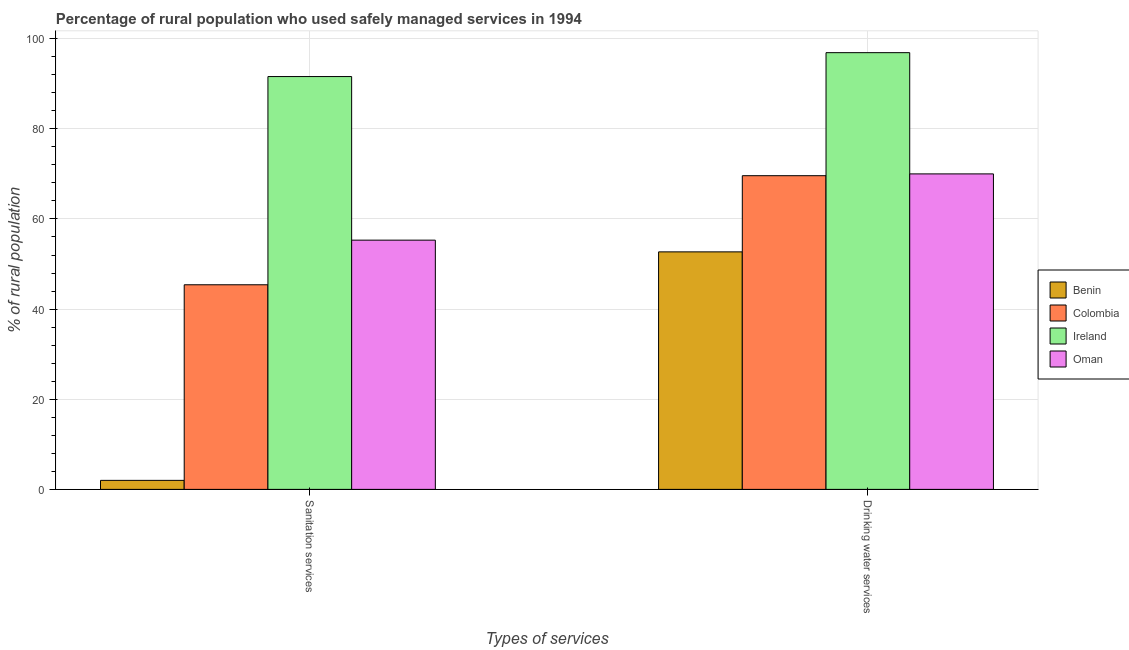Are the number of bars on each tick of the X-axis equal?
Give a very brief answer. Yes. What is the label of the 1st group of bars from the left?
Give a very brief answer. Sanitation services. What is the percentage of rural population who used sanitation services in Oman?
Offer a terse response. 55.3. Across all countries, what is the maximum percentage of rural population who used drinking water services?
Offer a very short reply. 96.9. Across all countries, what is the minimum percentage of rural population who used drinking water services?
Make the answer very short. 52.7. In which country was the percentage of rural population who used sanitation services maximum?
Offer a very short reply. Ireland. In which country was the percentage of rural population who used sanitation services minimum?
Keep it short and to the point. Benin. What is the total percentage of rural population who used sanitation services in the graph?
Your answer should be very brief. 194.3. What is the difference between the percentage of rural population who used sanitation services in Colombia and that in Ireland?
Offer a terse response. -46.2. What is the difference between the percentage of rural population who used sanitation services in Ireland and the percentage of rural population who used drinking water services in Colombia?
Provide a short and direct response. 22. What is the average percentage of rural population who used sanitation services per country?
Make the answer very short. 48.58. What is the difference between the percentage of rural population who used drinking water services and percentage of rural population who used sanitation services in Benin?
Provide a succinct answer. 50.7. In how many countries, is the percentage of rural population who used sanitation services greater than 80 %?
Your answer should be very brief. 1. What is the ratio of the percentage of rural population who used sanitation services in Oman to that in Colombia?
Your answer should be compact. 1.22. Is the percentage of rural population who used drinking water services in Colombia less than that in Oman?
Provide a succinct answer. Yes. In how many countries, is the percentage of rural population who used sanitation services greater than the average percentage of rural population who used sanitation services taken over all countries?
Ensure brevity in your answer.  2. What does the 4th bar from the left in Sanitation services represents?
Your response must be concise. Oman. Are all the bars in the graph horizontal?
Make the answer very short. No. Are the values on the major ticks of Y-axis written in scientific E-notation?
Offer a very short reply. No. Does the graph contain any zero values?
Your answer should be compact. No. Where does the legend appear in the graph?
Your response must be concise. Center right. What is the title of the graph?
Offer a very short reply. Percentage of rural population who used safely managed services in 1994. What is the label or title of the X-axis?
Ensure brevity in your answer.  Types of services. What is the label or title of the Y-axis?
Make the answer very short. % of rural population. What is the % of rural population in Benin in Sanitation services?
Your response must be concise. 2. What is the % of rural population in Colombia in Sanitation services?
Your answer should be very brief. 45.4. What is the % of rural population in Ireland in Sanitation services?
Your response must be concise. 91.6. What is the % of rural population in Oman in Sanitation services?
Ensure brevity in your answer.  55.3. What is the % of rural population in Benin in Drinking water services?
Your response must be concise. 52.7. What is the % of rural population of Colombia in Drinking water services?
Offer a very short reply. 69.6. What is the % of rural population of Ireland in Drinking water services?
Provide a short and direct response. 96.9. What is the % of rural population in Oman in Drinking water services?
Give a very brief answer. 70. Across all Types of services, what is the maximum % of rural population in Benin?
Keep it short and to the point. 52.7. Across all Types of services, what is the maximum % of rural population in Colombia?
Provide a succinct answer. 69.6. Across all Types of services, what is the maximum % of rural population in Ireland?
Your answer should be compact. 96.9. Across all Types of services, what is the minimum % of rural population of Colombia?
Keep it short and to the point. 45.4. Across all Types of services, what is the minimum % of rural population in Ireland?
Give a very brief answer. 91.6. Across all Types of services, what is the minimum % of rural population of Oman?
Your answer should be very brief. 55.3. What is the total % of rural population of Benin in the graph?
Your answer should be compact. 54.7. What is the total % of rural population of Colombia in the graph?
Your response must be concise. 115. What is the total % of rural population of Ireland in the graph?
Provide a succinct answer. 188.5. What is the total % of rural population in Oman in the graph?
Your answer should be compact. 125.3. What is the difference between the % of rural population of Benin in Sanitation services and that in Drinking water services?
Provide a succinct answer. -50.7. What is the difference between the % of rural population of Colombia in Sanitation services and that in Drinking water services?
Your answer should be very brief. -24.2. What is the difference between the % of rural population in Oman in Sanitation services and that in Drinking water services?
Your answer should be compact. -14.7. What is the difference between the % of rural population in Benin in Sanitation services and the % of rural population in Colombia in Drinking water services?
Offer a very short reply. -67.6. What is the difference between the % of rural population in Benin in Sanitation services and the % of rural population in Ireland in Drinking water services?
Give a very brief answer. -94.9. What is the difference between the % of rural population of Benin in Sanitation services and the % of rural population of Oman in Drinking water services?
Provide a short and direct response. -68. What is the difference between the % of rural population in Colombia in Sanitation services and the % of rural population in Ireland in Drinking water services?
Provide a succinct answer. -51.5. What is the difference between the % of rural population in Colombia in Sanitation services and the % of rural population in Oman in Drinking water services?
Your response must be concise. -24.6. What is the difference between the % of rural population in Ireland in Sanitation services and the % of rural population in Oman in Drinking water services?
Your response must be concise. 21.6. What is the average % of rural population of Benin per Types of services?
Your answer should be compact. 27.35. What is the average % of rural population in Colombia per Types of services?
Provide a short and direct response. 57.5. What is the average % of rural population of Ireland per Types of services?
Ensure brevity in your answer.  94.25. What is the average % of rural population in Oman per Types of services?
Make the answer very short. 62.65. What is the difference between the % of rural population in Benin and % of rural population in Colombia in Sanitation services?
Keep it short and to the point. -43.4. What is the difference between the % of rural population of Benin and % of rural population of Ireland in Sanitation services?
Your response must be concise. -89.6. What is the difference between the % of rural population in Benin and % of rural population in Oman in Sanitation services?
Ensure brevity in your answer.  -53.3. What is the difference between the % of rural population of Colombia and % of rural population of Ireland in Sanitation services?
Ensure brevity in your answer.  -46.2. What is the difference between the % of rural population of Colombia and % of rural population of Oman in Sanitation services?
Provide a short and direct response. -9.9. What is the difference between the % of rural population in Ireland and % of rural population in Oman in Sanitation services?
Provide a short and direct response. 36.3. What is the difference between the % of rural population of Benin and % of rural population of Colombia in Drinking water services?
Give a very brief answer. -16.9. What is the difference between the % of rural population in Benin and % of rural population in Ireland in Drinking water services?
Your response must be concise. -44.2. What is the difference between the % of rural population in Benin and % of rural population in Oman in Drinking water services?
Make the answer very short. -17.3. What is the difference between the % of rural population of Colombia and % of rural population of Ireland in Drinking water services?
Your response must be concise. -27.3. What is the difference between the % of rural population of Ireland and % of rural population of Oman in Drinking water services?
Your answer should be very brief. 26.9. What is the ratio of the % of rural population of Benin in Sanitation services to that in Drinking water services?
Offer a terse response. 0.04. What is the ratio of the % of rural population of Colombia in Sanitation services to that in Drinking water services?
Your answer should be compact. 0.65. What is the ratio of the % of rural population of Ireland in Sanitation services to that in Drinking water services?
Make the answer very short. 0.95. What is the ratio of the % of rural population of Oman in Sanitation services to that in Drinking water services?
Your answer should be compact. 0.79. What is the difference between the highest and the second highest % of rural population in Benin?
Offer a very short reply. 50.7. What is the difference between the highest and the second highest % of rural population of Colombia?
Provide a short and direct response. 24.2. What is the difference between the highest and the second highest % of rural population of Ireland?
Your response must be concise. 5.3. What is the difference between the highest and the second highest % of rural population of Oman?
Your answer should be compact. 14.7. What is the difference between the highest and the lowest % of rural population in Benin?
Your answer should be very brief. 50.7. What is the difference between the highest and the lowest % of rural population of Colombia?
Offer a very short reply. 24.2. 